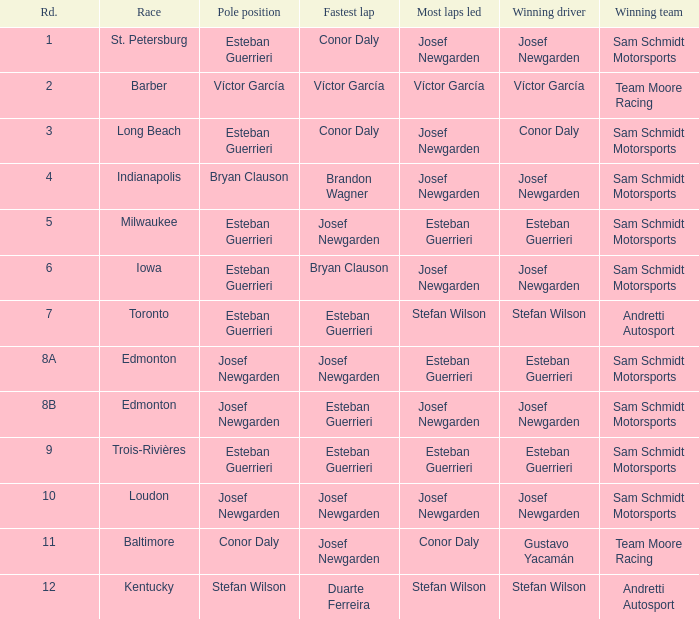When brandon wagner achieved the fastest lap, who was the leader for the most laps? Josef Newgarden. 